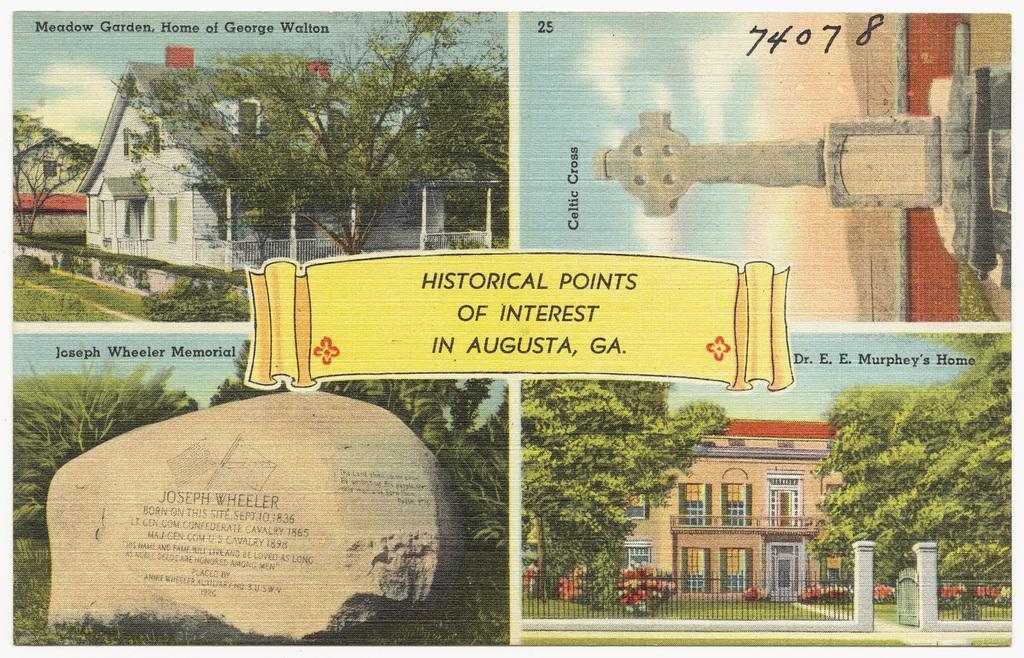Please provide a concise description of this image. In the picture we can see a magazine on it we can see four images, in the first image we can see a house, in the second image we can see a cross stone and in the third image we can see a rock on it we can see some information and beside it we can see plants, and in the fourth image we can see house building with windows and glass to it and in front of the building we can see railing and a gate. 